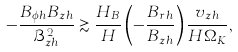<formula> <loc_0><loc_0><loc_500><loc_500>- \frac { B _ { \phi h } B _ { z h } } { \mathcal { B } _ { z h } ^ { 2 } } \gtrsim \frac { H _ { B } } { H } \left ( - \frac { B _ { r h } } { B _ { z h } } \right ) \frac { v _ { z h } } { H \Omega _ { K } } ,</formula> 